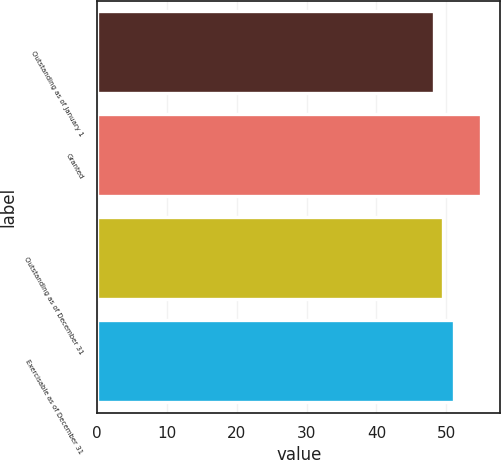Convert chart to OTSL. <chart><loc_0><loc_0><loc_500><loc_500><bar_chart><fcel>Outstanding as of January 1<fcel>Granted<fcel>Outstanding as of December 31<fcel>Exercisable as of December 31<nl><fcel>48.28<fcel>55<fcel>49.53<fcel>51.06<nl></chart> 